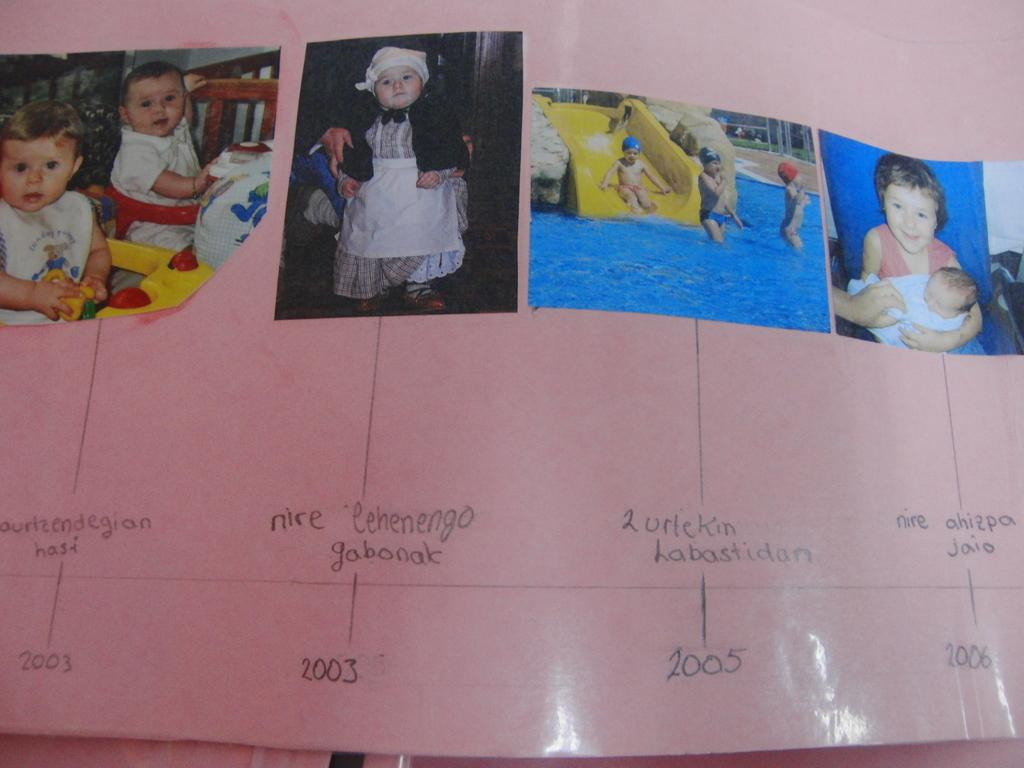What is present in the image that contains both text and images? There is a poster in the image that contains text and images. Can you describe the content of the poster? The poster contains text and images, but the specific content cannot be determined from the provided facts. What is the condition of the zebra in the image? There is no zebra present in the image, so its condition cannot be determined. 